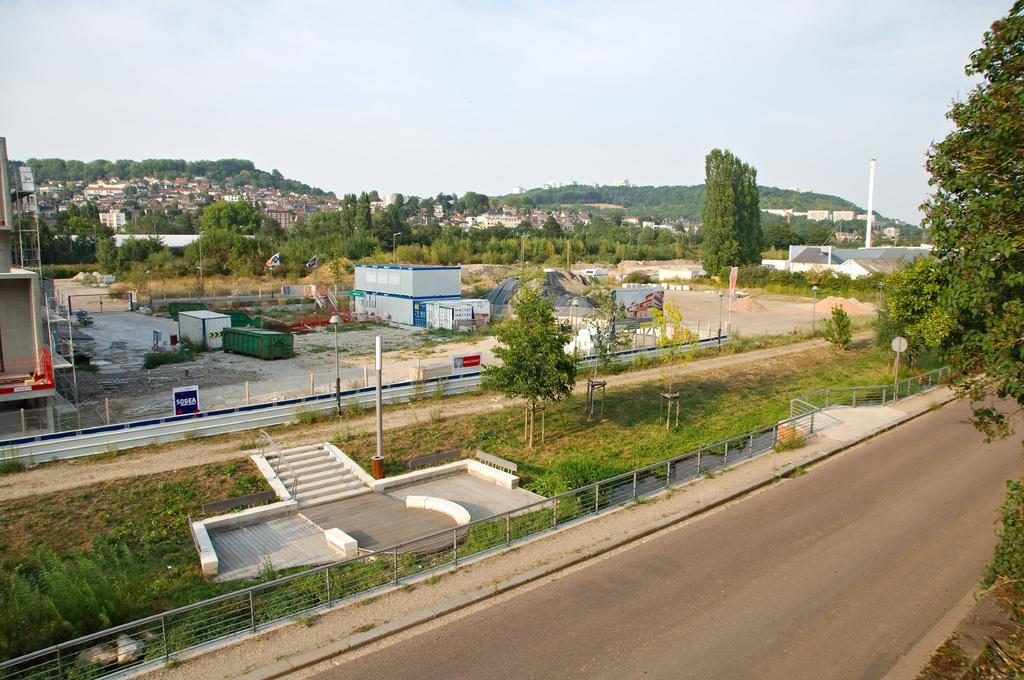Describe this image in one or two sentences. In this image I can see the road. On both sides of the road I can see the trees. In the background I can see the railing, poles, boards and the containers. I can also see many buildings, trees, mountains and the sky. 